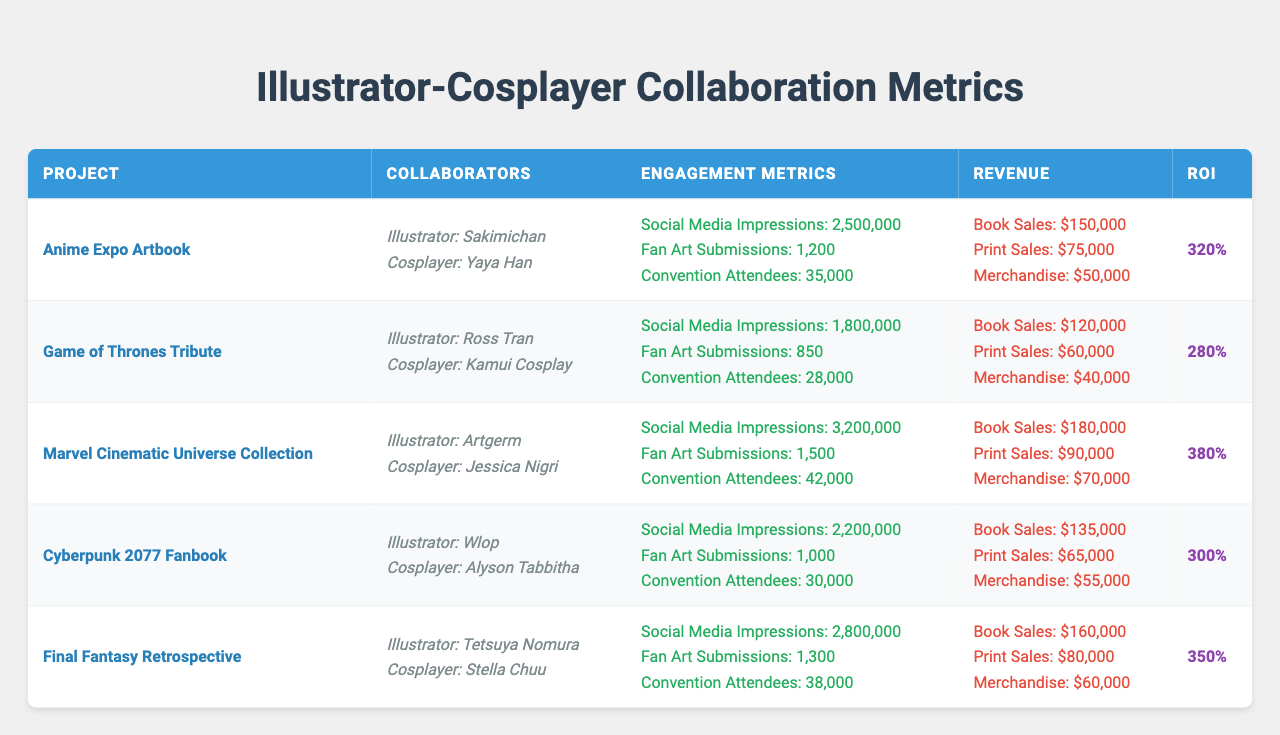What is the project with the highest social media impressions? The table lists the "Marvel Cinematic Universe Collection" with 3,200,000 social media impressions, which is higher than all other projects.
Answer: Marvel Cinematic Universe Collection Which project had the least revenue from merchandise sales? The "Game of Thrones Tribute" project had $40,000 in merchandise sales, which is the lowest compared to the others listed in the table.
Answer: Game of Thrones Tribute What is the total revenue generated by the "Cyberpunk 2077 Fanbook"? The total revenue is calculated by summing the individual revenue streams: Book Sales ($135,000) + Print Sales ($65,000) + Merchandise ($55,000) = $255,000.
Answer: $255,000 What percentage of the total revenue for the "Final Fantasy Retrospective" comes from book sales? Total revenue is $300,000; book sales are $160,000. To find the percentage: (160,000 / 300,000) * 100 = 53.33%.
Answer: 53.33% Which illustrator has collaborated with the most well-known cosplayer based on social media presence? Based on the projects listed, "Artgerm" collaborated with "Jessica Nigri," who is recognized widely in the cosplay community, particularly given the high engagement metrics of their project.
Answer: Artgerm and Jessica Nigri How does the ROI of the "Anime Expo Artbook" compare to the "Cyberpunk 2077 Fanbook"? The ROI for the "Anime Expo Artbook" is 320%, while the "Cyberpunk 2077 Fanbook" has an ROI of 300%. Since 320 is greater than 300, it indicates that the "Anime Expo Artbook" is more profitable in relative terms.
Answer: Higher ROI for Anime Expo Artbook What is the average ROI across all projects? The total ROI of all projects is (320 + 280 + 380 + 300 + 350) = 1,630, divided by the number of projects (5), gives an average ROI of 326%.
Answer: 326% Is the "Cyberpunk 2077 Fanbook" rated better or worse in terms of engagement (total impressions) compared to the "Game of Thrones Tribute"? "Cyberpunk 2077 Fanbook" has 2,200,000 impressions, while "Game of Thrones Tribute" has 1,800,000. Since 2,200,000 is greater than 1,800,000, it indicates a better engagement rating for the Cyberpunk project.
Answer: Better engagement for Cyberpunk 2077 Fanbook What is the difference in fan art submissions between the project with the highest and lowest submissions? The highest fan art submissions were 1,500 for the "Marvel Cinematic Universe Collection" and the lowest were 850 for the "Game of Thrones Tribute." The difference is calculated as 1,500 - 850 = 650.
Answer: 650 submissions Which project had a greater number of convention attendees, the "Anime Expo Artbook" or the "Final Fantasy Retrospective"? The "Anime Expo Artbook" had 35,000 attendees, while the "Final Fantasy Retrospective" had 38,000 attendees. Since 38,000 is greater than 35,000, the "Final Fantasy Retrospective" had more attendees.
Answer: Final Fantasy Retrospective What was the total engagement (considering impressions, fan art submissions, and attendees) for the "Game of Thrones Tribute"? Total engagement is calculated by adding the figures: 1,800,000 impressions + 850 submissions + 28,000 attendees = 1,828,850.
Answer: 1,828,850 